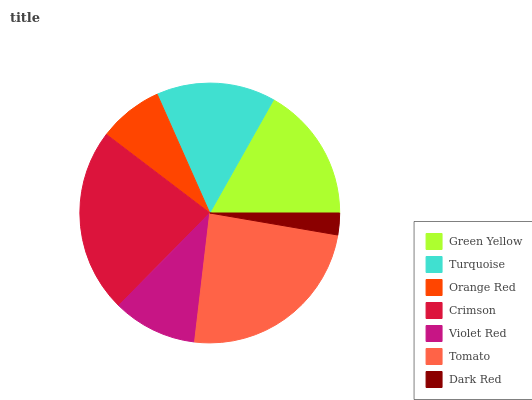Is Dark Red the minimum?
Answer yes or no. Yes. Is Tomato the maximum?
Answer yes or no. Yes. Is Turquoise the minimum?
Answer yes or no. No. Is Turquoise the maximum?
Answer yes or no. No. Is Green Yellow greater than Turquoise?
Answer yes or no. Yes. Is Turquoise less than Green Yellow?
Answer yes or no. Yes. Is Turquoise greater than Green Yellow?
Answer yes or no. No. Is Green Yellow less than Turquoise?
Answer yes or no. No. Is Turquoise the high median?
Answer yes or no. Yes. Is Turquoise the low median?
Answer yes or no. Yes. Is Crimson the high median?
Answer yes or no. No. Is Crimson the low median?
Answer yes or no. No. 